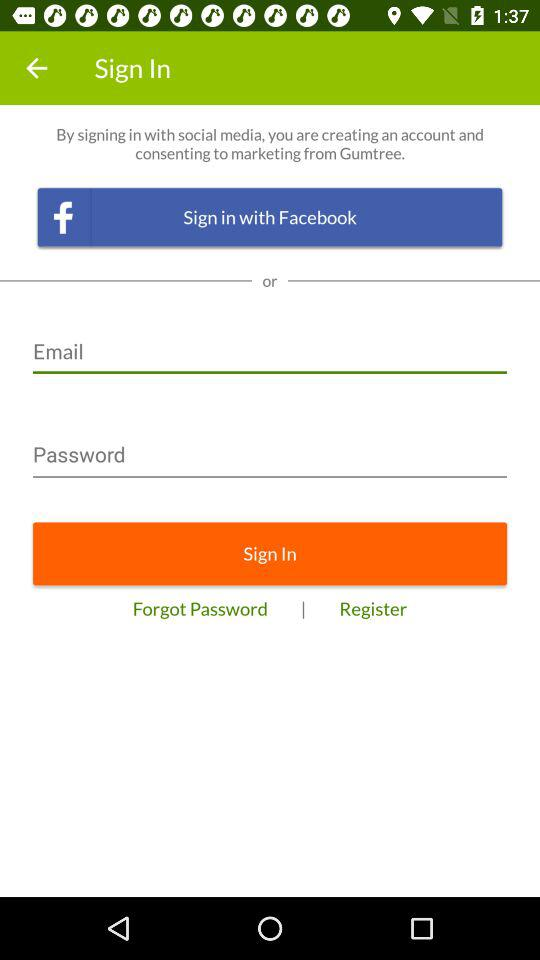What social app can we use to log in? You can log in with "Facebook". 